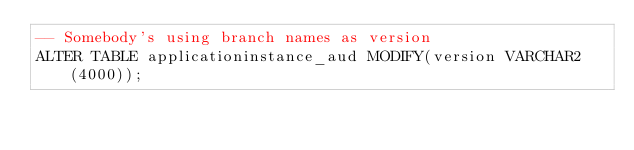Convert code to text. <code><loc_0><loc_0><loc_500><loc_500><_SQL_>-- Somebody's using branch names as version
ALTER TABLE applicationinstance_aud MODIFY(version VARCHAR2(4000));
</code> 